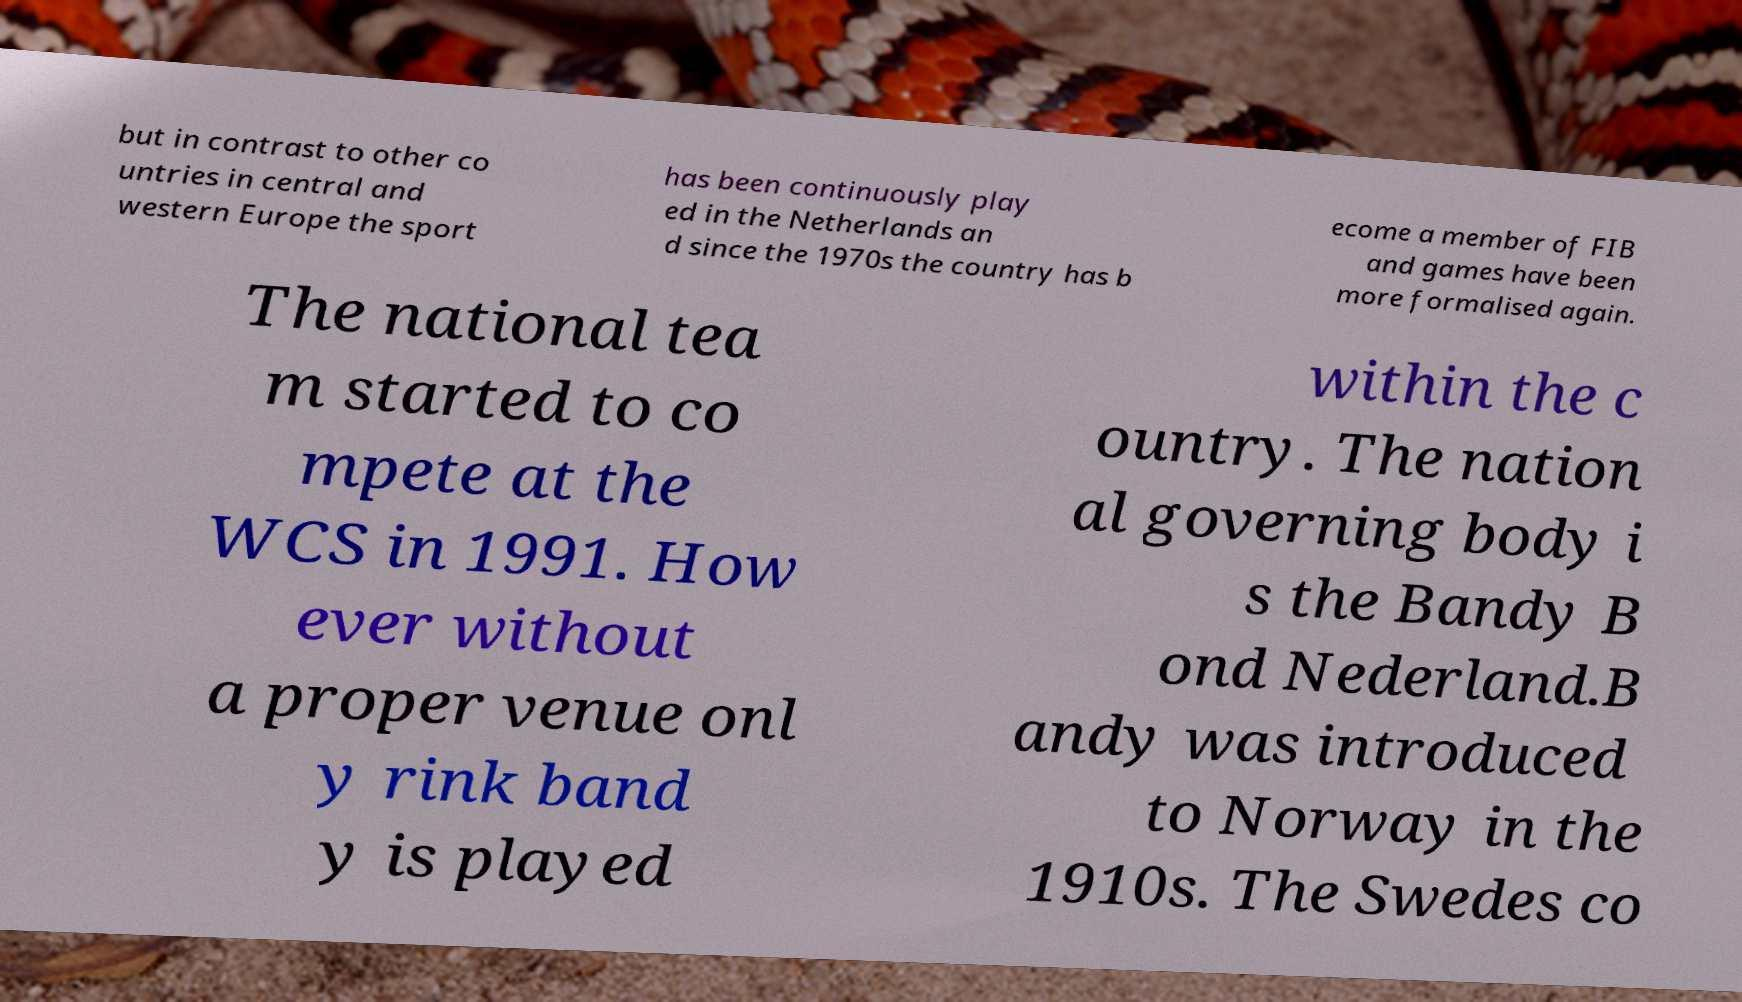Please identify and transcribe the text found in this image. but in contrast to other co untries in central and western Europe the sport has been continuously play ed in the Netherlands an d since the 1970s the country has b ecome a member of FIB and games have been more formalised again. The national tea m started to co mpete at the WCS in 1991. How ever without a proper venue onl y rink band y is played within the c ountry. The nation al governing body i s the Bandy B ond Nederland.B andy was introduced to Norway in the 1910s. The Swedes co 